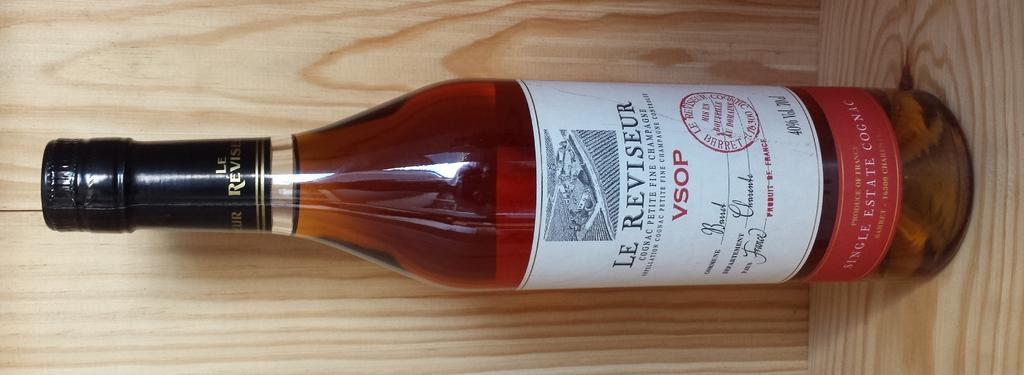Provide a one-sentence caption for the provided image. The bottle of liquid has VSOP and Le REViseur on it and it's full. 